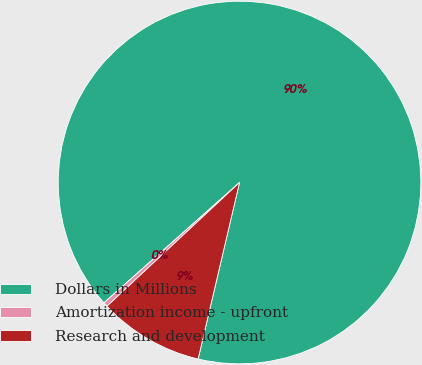<chart> <loc_0><loc_0><loc_500><loc_500><pie_chart><fcel>Dollars in Millions<fcel>Amortization income - upfront<fcel>Research and development<nl><fcel>90.21%<fcel>0.4%<fcel>9.38%<nl></chart> 